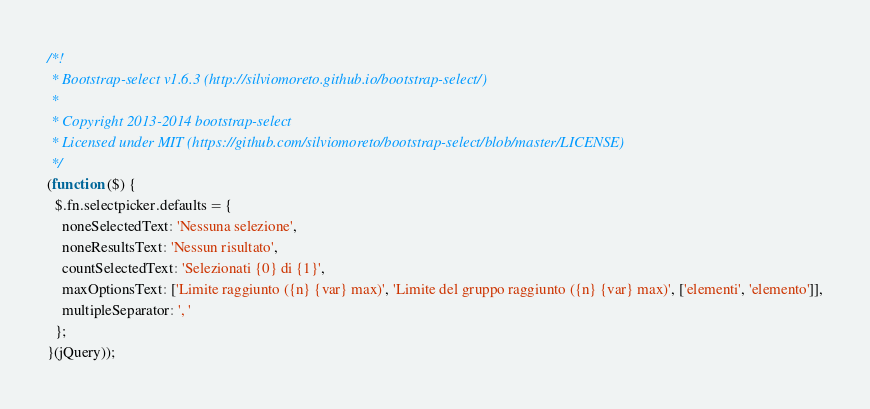<code> <loc_0><loc_0><loc_500><loc_500><_JavaScript_>/*!
 * Bootstrap-select v1.6.3 (http://silviomoreto.github.io/bootstrap-select/)
 *
 * Copyright 2013-2014 bootstrap-select
 * Licensed under MIT (https://github.com/silviomoreto/bootstrap-select/blob/master/LICENSE)
 */
(function ($) {
  $.fn.selectpicker.defaults = {
    noneSelectedText: 'Nessuna selezione',
    noneResultsText: 'Nessun risultato',
    countSelectedText: 'Selezionati {0} di {1}',
    maxOptionsText: ['Limite raggiunto ({n} {var} max)', 'Limite del gruppo raggiunto ({n} {var} max)', ['elementi', 'elemento']],
    multipleSeparator: ', '
  };
}(jQuery));
</code> 